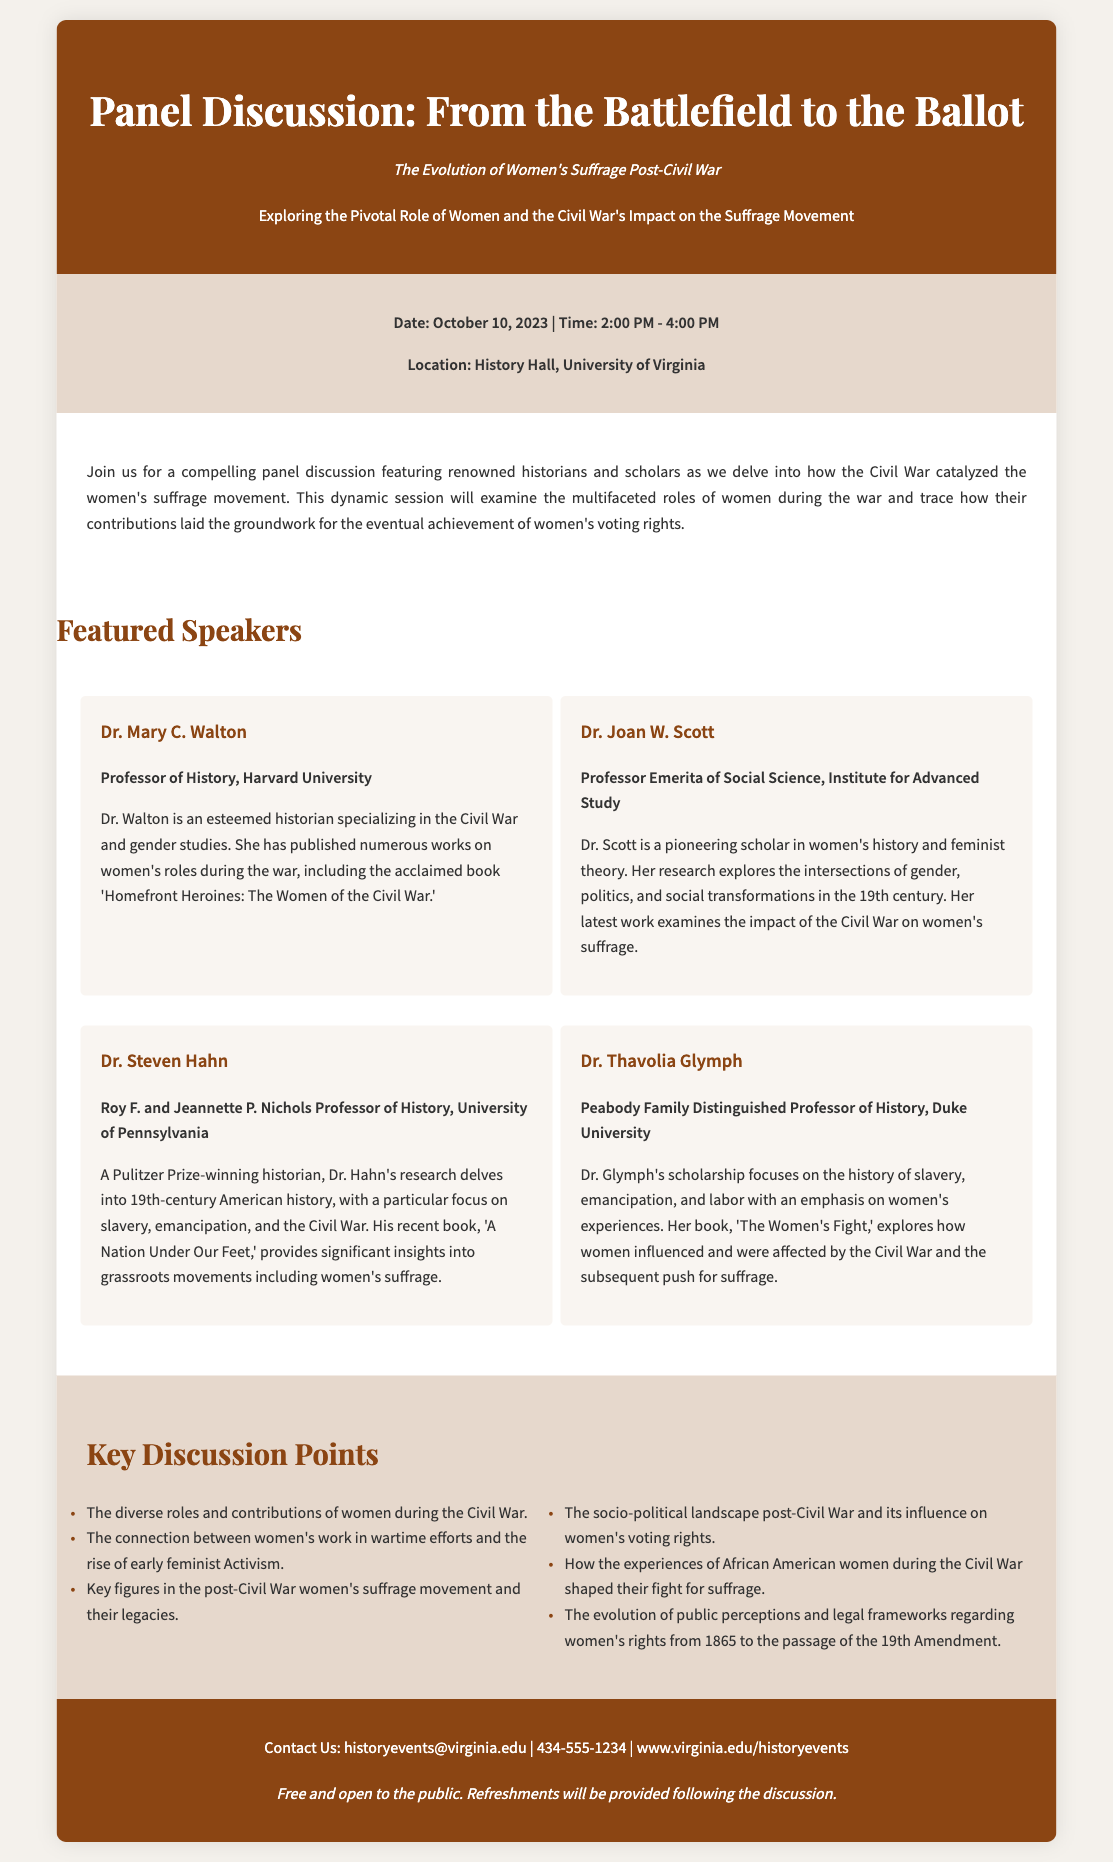What is the date of the panel discussion? The date is specifically mentioned in the event details section of the document.
Answer: October 10, 2023 Who is the professor of history from Harvard University? The document provides speaker profiles, including their titles and institutions.
Answer: Dr. Mary C. Walton What time does the panel discussion start? The start time is included in the event details section and is listed explicitly.
Answer: 2:00 PM Which university is Dr. Thavolia Glymph affiliated with? The speaker profiles contain the names of universities affiliated with each speaker.
Answer: Duke University What is a key discussion point mentioned in the document? The document lists several discussion points that participants will cover during the panel.
Answer: The diverse roles and contributions of women during the Civil War How many speakers are featured in the panel discussion? The number of speakers can be counted in the speakers section of the document.
Answer: Four What is provided after the discussion? The footer mentions something specific that will follow the panel discussion.
Answer: Refreshments What is the location of the event? The location is detailed in the event details section of the document.
Answer: History Hall, University of Virginia 